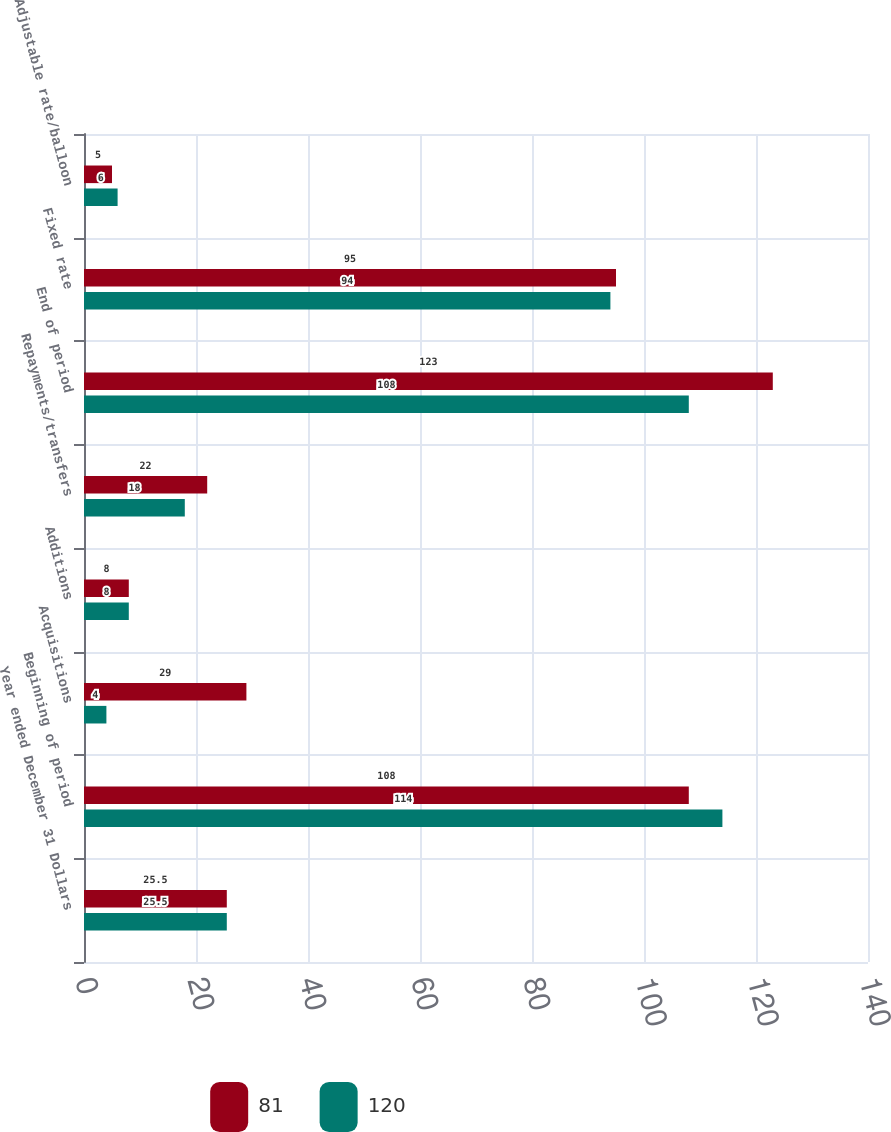<chart> <loc_0><loc_0><loc_500><loc_500><stacked_bar_chart><ecel><fcel>Year ended December 31 Dollars<fcel>Beginning of period<fcel>Acquisitions<fcel>Additions<fcel>Repayments/transfers<fcel>End of period<fcel>Fixed rate<fcel>Adjustable rate/balloon<nl><fcel>81<fcel>25.5<fcel>108<fcel>29<fcel>8<fcel>22<fcel>123<fcel>95<fcel>5<nl><fcel>120<fcel>25.5<fcel>114<fcel>4<fcel>8<fcel>18<fcel>108<fcel>94<fcel>6<nl></chart> 